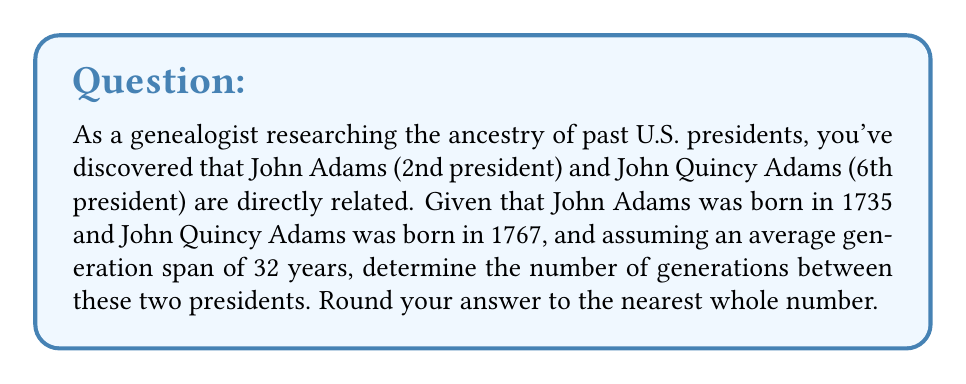Can you answer this question? To solve this problem, we need to follow these steps:

1. Calculate the time difference between the birth years of the two presidents:
   $1767 - 1735 = 32$ years

2. Divide this time difference by the average generation span:
   $\frac{32 \text{ years}}{32 \text{ years/generation}} = 1$

3. Since we're asked to round to the nearest whole number, we don't need to perform any additional rounding in this case.

It's important to note that in reality, John Quincy Adams was the son of John Adams, which aligns perfectly with our calculated result of 1 generation.

In general, for any two related presidents born in years $y_1$ and $y_2$ (where $y_2 > y_1$), with an average generation span of $g$ years, the number of generations $n$ between them can be calculated and rounded as follows:

$$n = \text{round}\left(\frac{y_2 - y_1}{g}\right)$$

Where the $\text{round}$ function rounds to the nearest integer.
Answer: 1 generation 